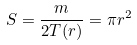Convert formula to latex. <formula><loc_0><loc_0><loc_500><loc_500>S = \frac { m } { 2 T ( r ) } = \pi r ^ { 2 }</formula> 